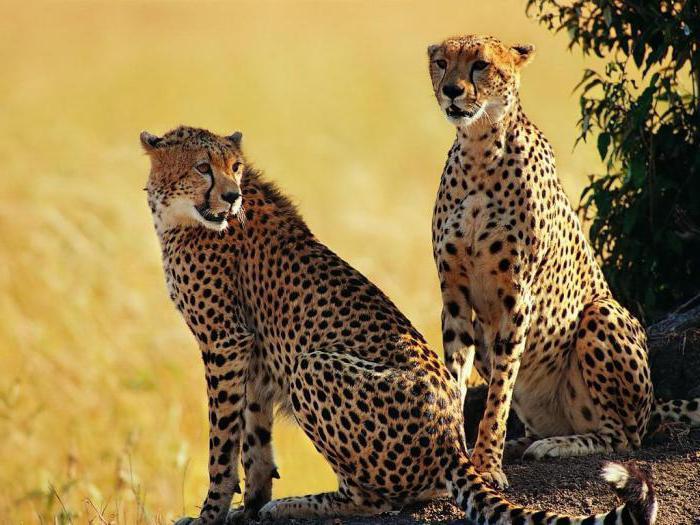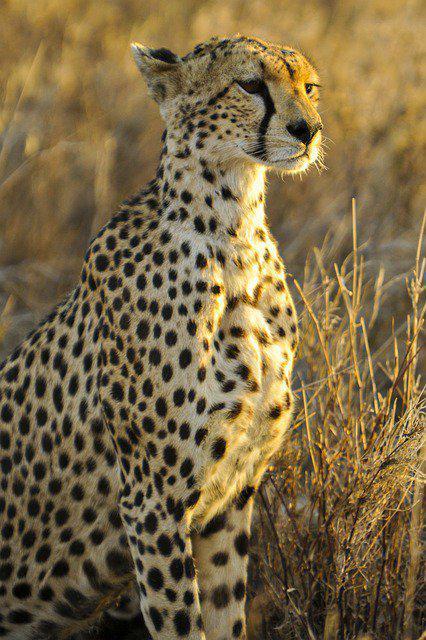The first image is the image on the left, the second image is the image on the right. Considering the images on both sides, is "The right image contains half as many cheetahs as the left image." valid? Answer yes or no. Yes. The first image is the image on the left, the second image is the image on the right. Examine the images to the left and right. Is the description "The left image contains exactly two cheetahs." accurate? Answer yes or no. Yes. 